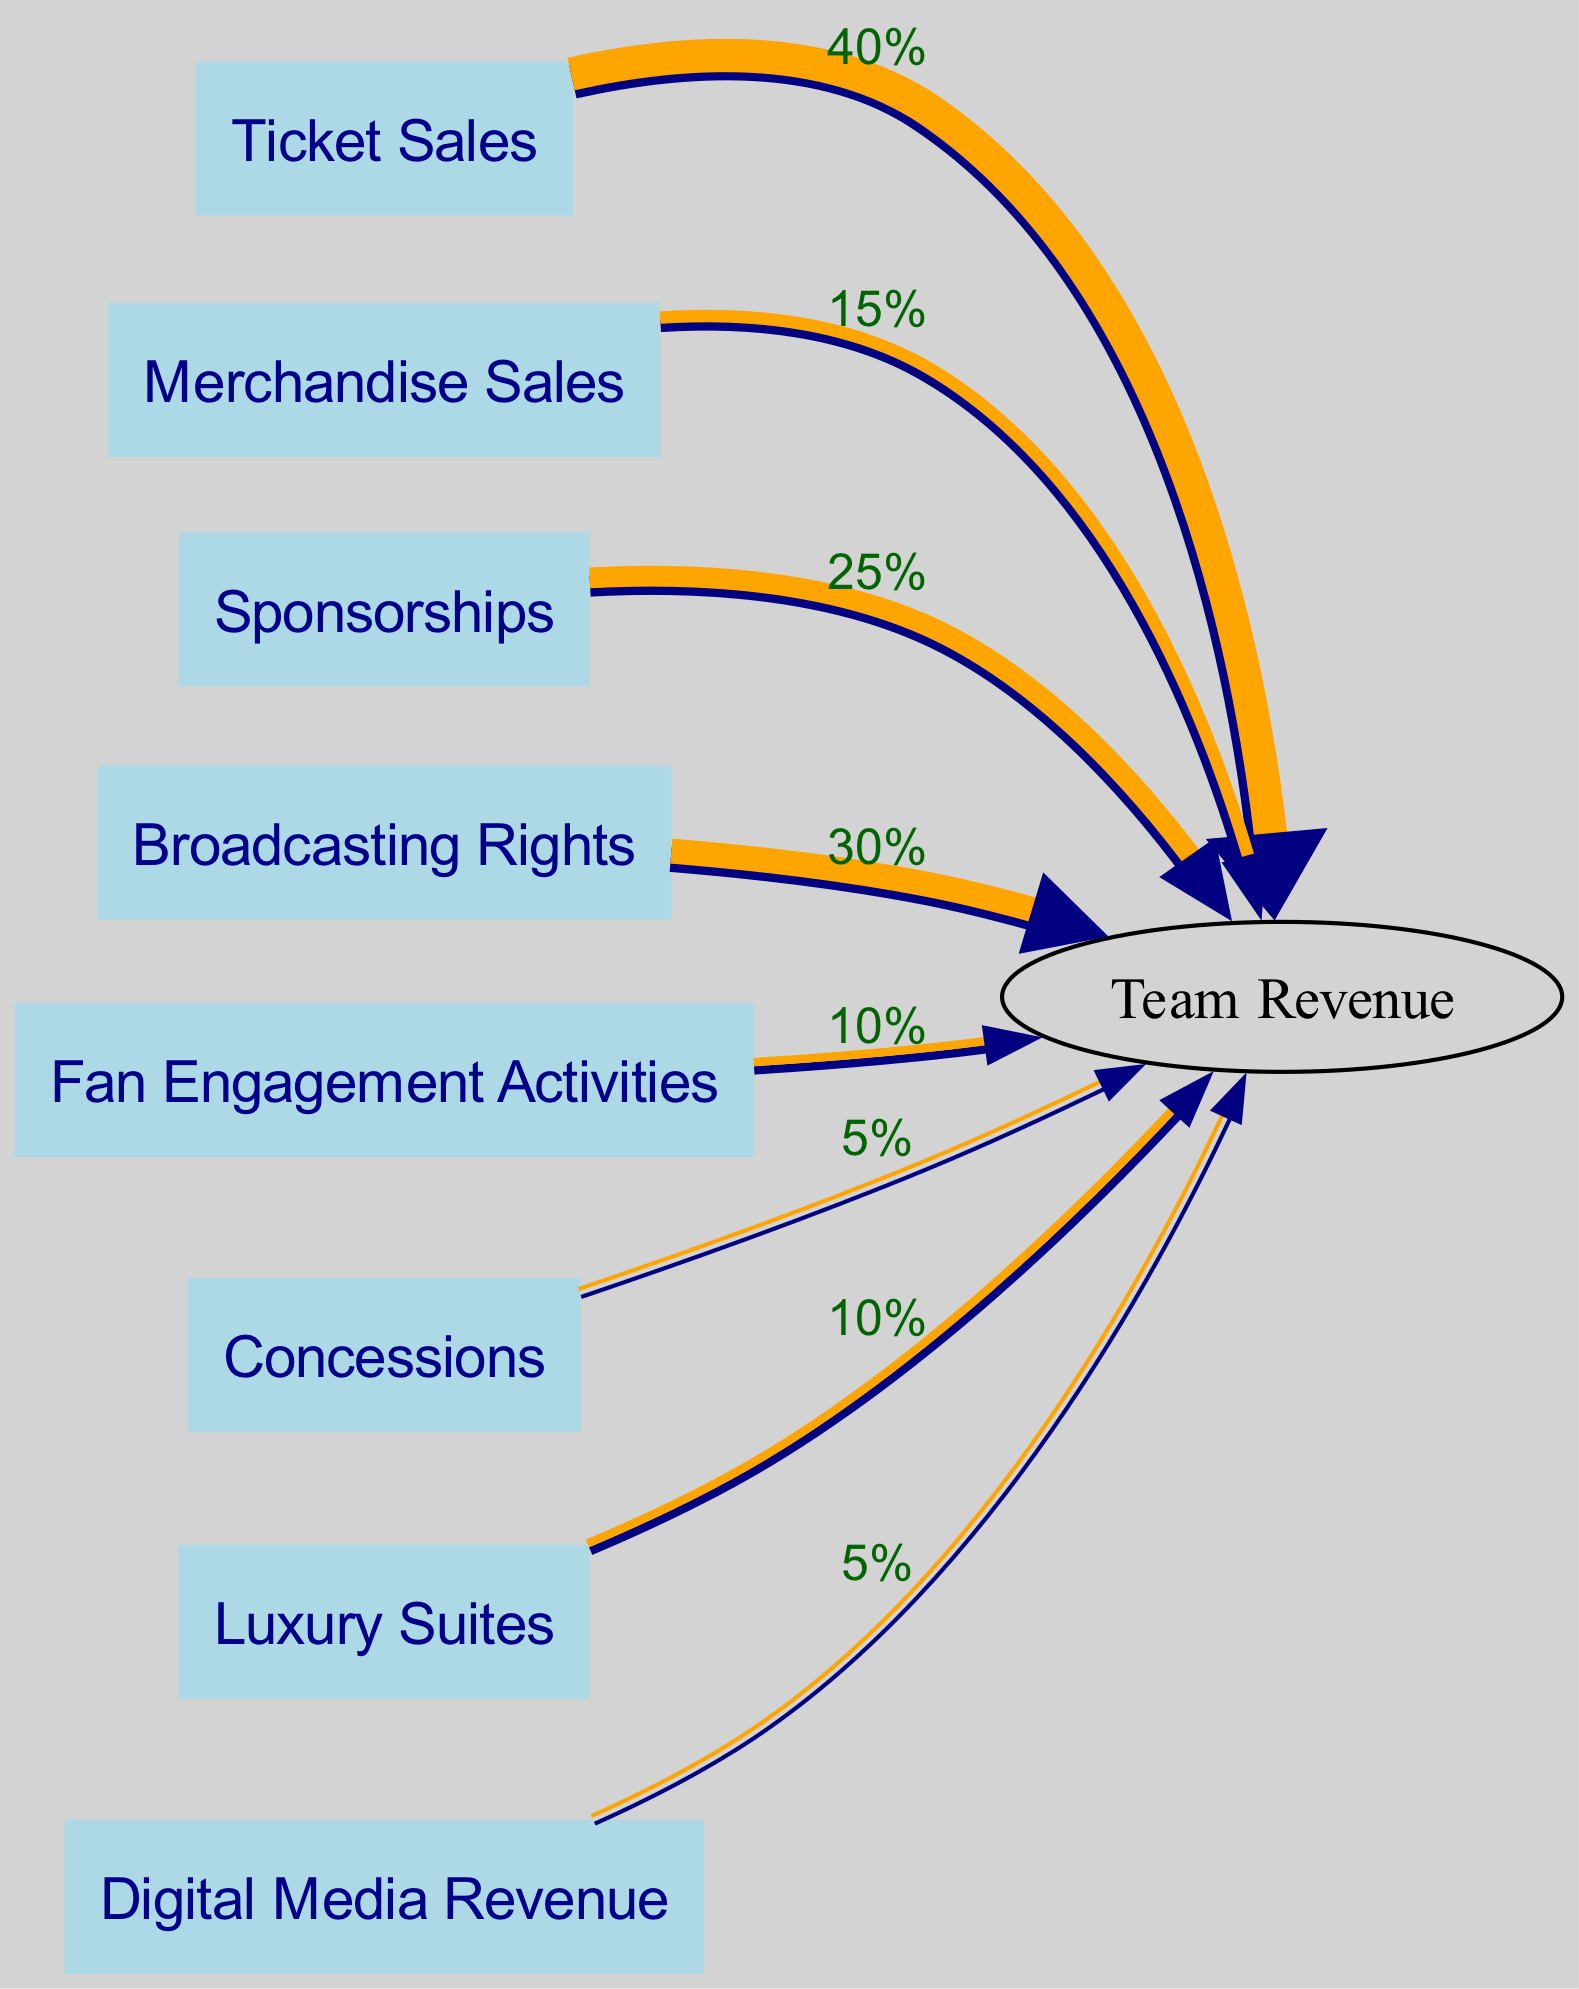What percentage of revenue comes from ticket sales? The diagram indicates that ticket sales contribute 40% to team revenue. This can be found directly from the flow where ticket sales lead to team revenue.
Answer: 40% Which revenue source has the lowest contribution? By examining the diagram, I note that concessions and digital media revenue both contribute 5%, which is the smallest amount when compared to other sources.
Answer: 5% How many total revenue sources are illustrated in the diagram? The diagram lists eight distinct nodes representing various revenue sources like ticket sales, merchandise sales, and more. Counting each node yields a total of eight.
Answer: 8 What is the combined revenue percentage from merchandise sales and sponsorships? Merchandise sales account for 15% and sponsorships for 25%. By adding these two percentages together (15% + 25%), I find that the combined total is 40%.
Answer: 40% Which sources contribute equally to the team revenue? The diagram shows that fan engagement activities and luxury suites both contribute 10% each, indicating they have equal contributions to the team revenue.
Answer: Fan engagement activities and luxury suites What is the percentage of revenue generated from broadcasting rights? Observing the diagram, it clearly shows broadcasting rights contributing 30% to team revenue. This information is directly presented on the link from broadcasting rights to team revenue.
Answer: 30% How much total revenue comes from concessions and digital media revenue combined? Concessions contribute 5% and digital media revenue also contributes 5%. Adding these two amounts together (5% + 5%) provides the total, which is 10%.
Answer: 10% What percentage of the team's revenue comes from sources other than ticket sales? Totaling the percentages from merchandise sales (15%), sponsorships (25%), broadcasting rights (30%), fan engagement activities (10%), concessions (5%), luxury suites (10%), and digital media revenue (5%) results in 95%. This indicates that if ticket sales are excluded (40%), the remaining sources contribute 60% to overall revenue.
Answer: 60% How does merchandise sales revenue compare to digital media revenue? The diagram shows merchandise sales at 15% while digital media revenue is at 5%. By comparing these two percentages, it's clear that merchandise sales revenue exceeds digital media revenue by 10%.
Answer: Merchandise sales exceed by 10% 